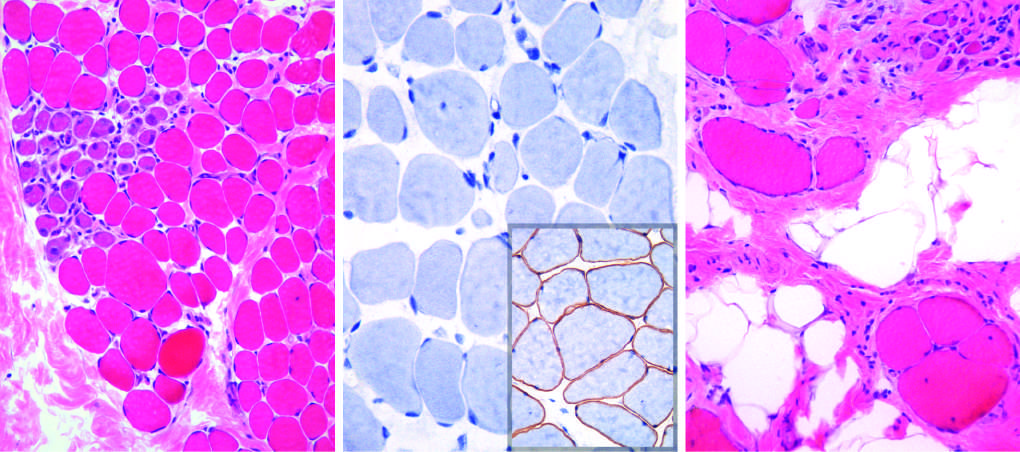does the biopsy from the older brother illustrate disease progression, which is marked by extensive variation in myofiber size, fatty replacement, and endomysial fibrosis in (c)?
Answer the question using a single word or phrase. Yes 